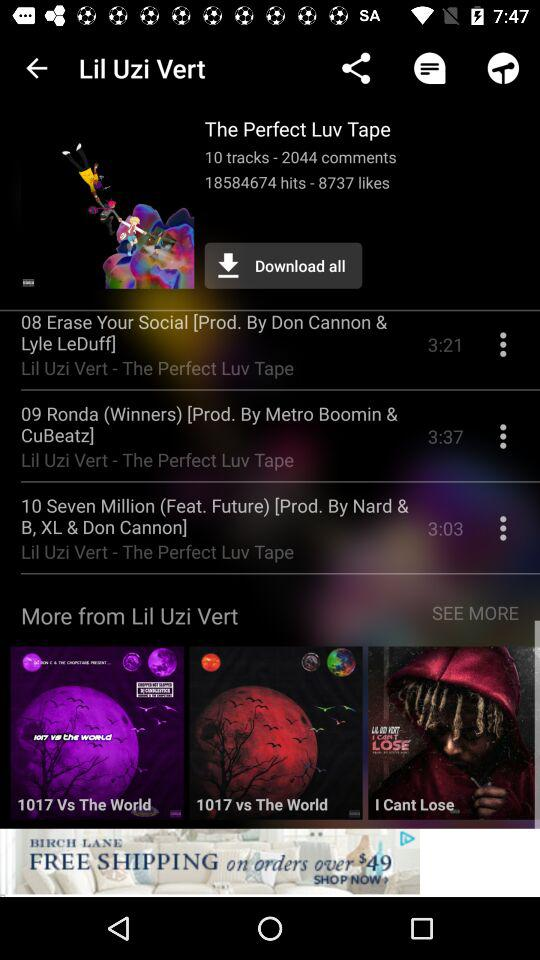How many likes in this? There are 8737 likes. 